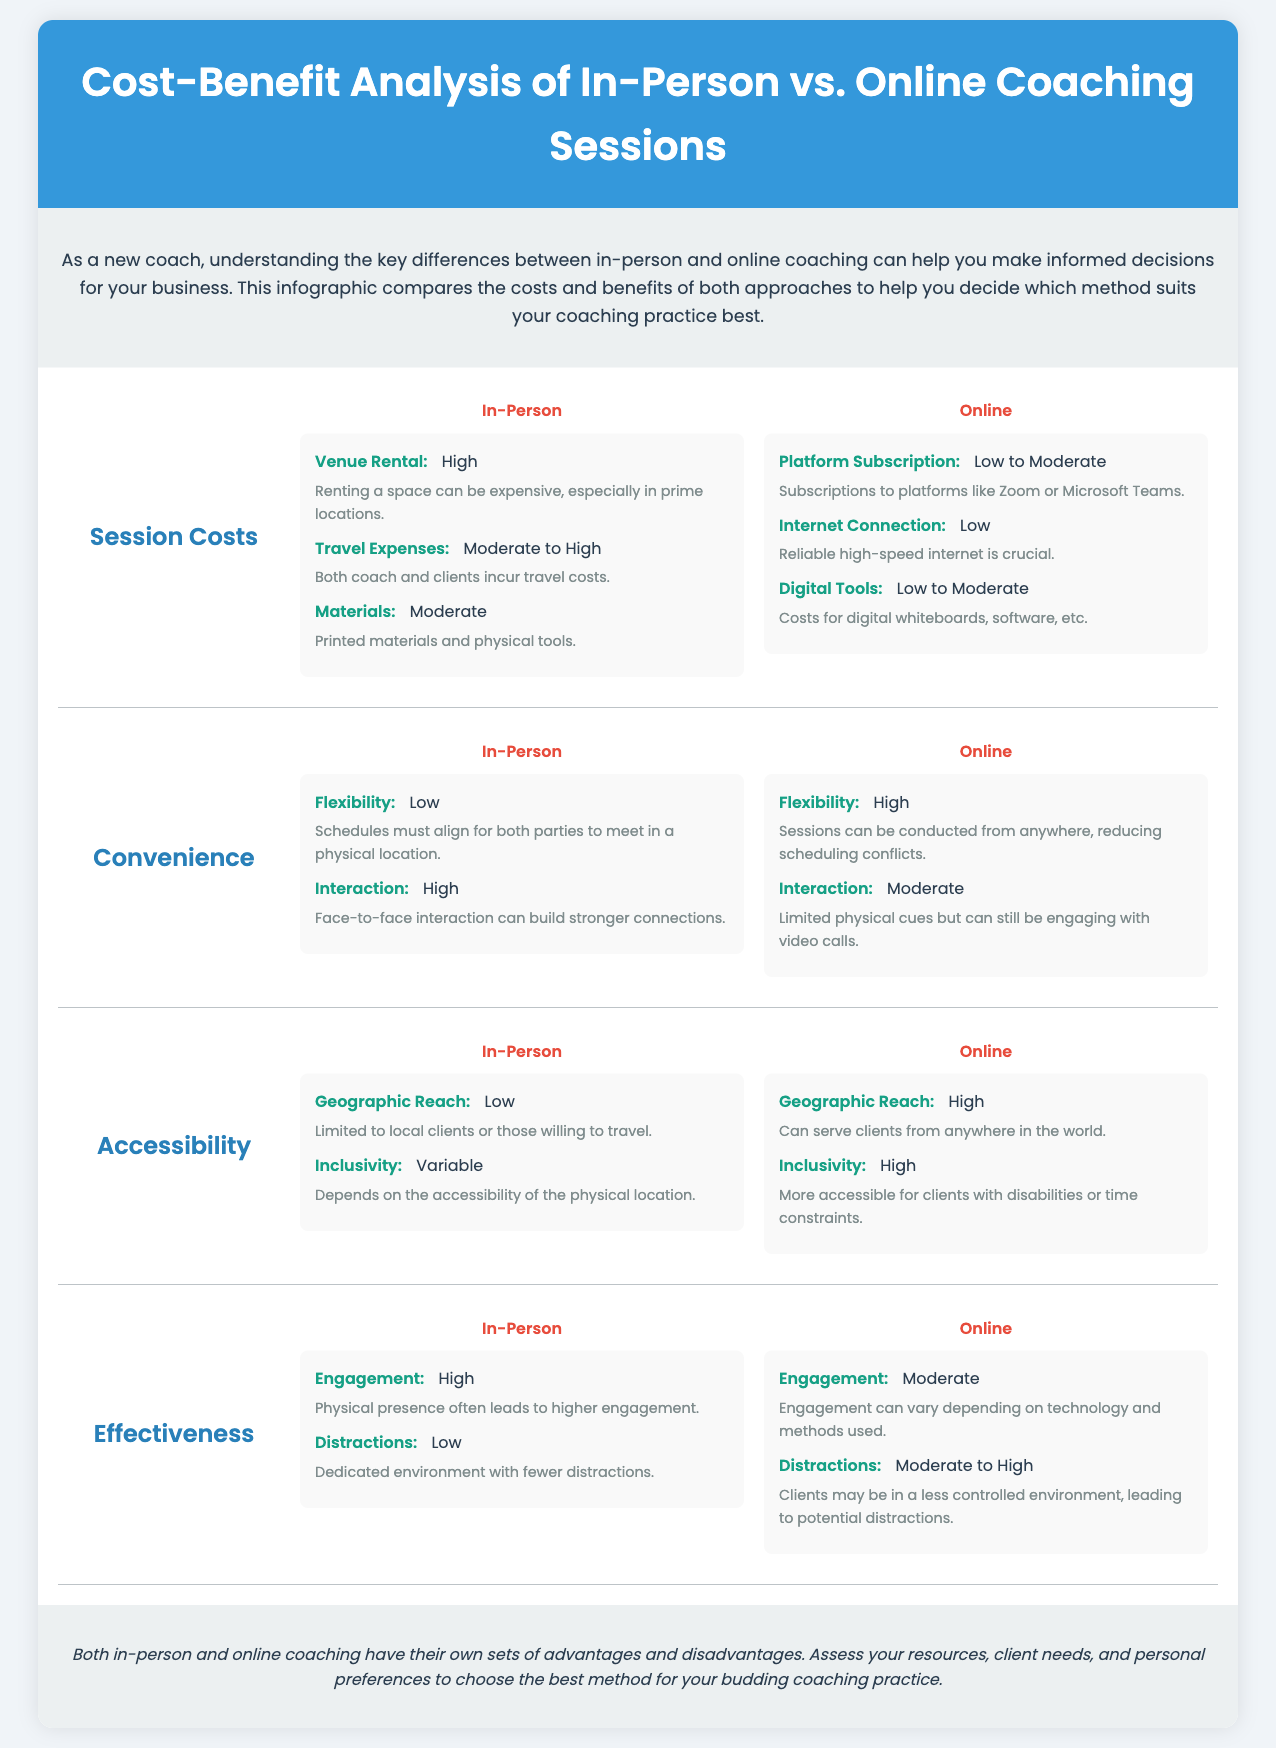What is the cost of venue rental in in-person coaching? The document states that the venue rental cost for in-person coaching is categorized as High.
Answer: High What are the travel expenses for in-person coaching? According to the document, travel expenses are classified as Moderate to High for in-person coaching.
Answer: Moderate to High What is the flexibility rating for online coaching? The flexibility for online coaching is rated as High according to the infographic.
Answer: High What is the geographic reach for online coaching? The document indicates that the geographic reach for online coaching is classified as High.
Answer: High What is the engagement level of in-person coaching? The engagement level for in-person coaching is described as High in the document.
Answer: High What is the primary advantage of online coaching in terms of accessibility? The primary advantage for online coaching is its High inclusivity for clients with disabilities or time constraints.
Answer: High Which type of coaching incurs lower internet connection costs? The infographic specifies that online coaching has Low internet connection costs.
Answer: Low Which aspect has higher interaction in coaching sessions? In-person coaching has a higher interaction rating compared to online coaching, as stated in the document.
Answer: High What is the overall conclusion drawn in the infographic? The conclusion emphasizes assessing resources, client needs, and personal preferences for the best coaching method.
Answer: Assess resources and client needs 